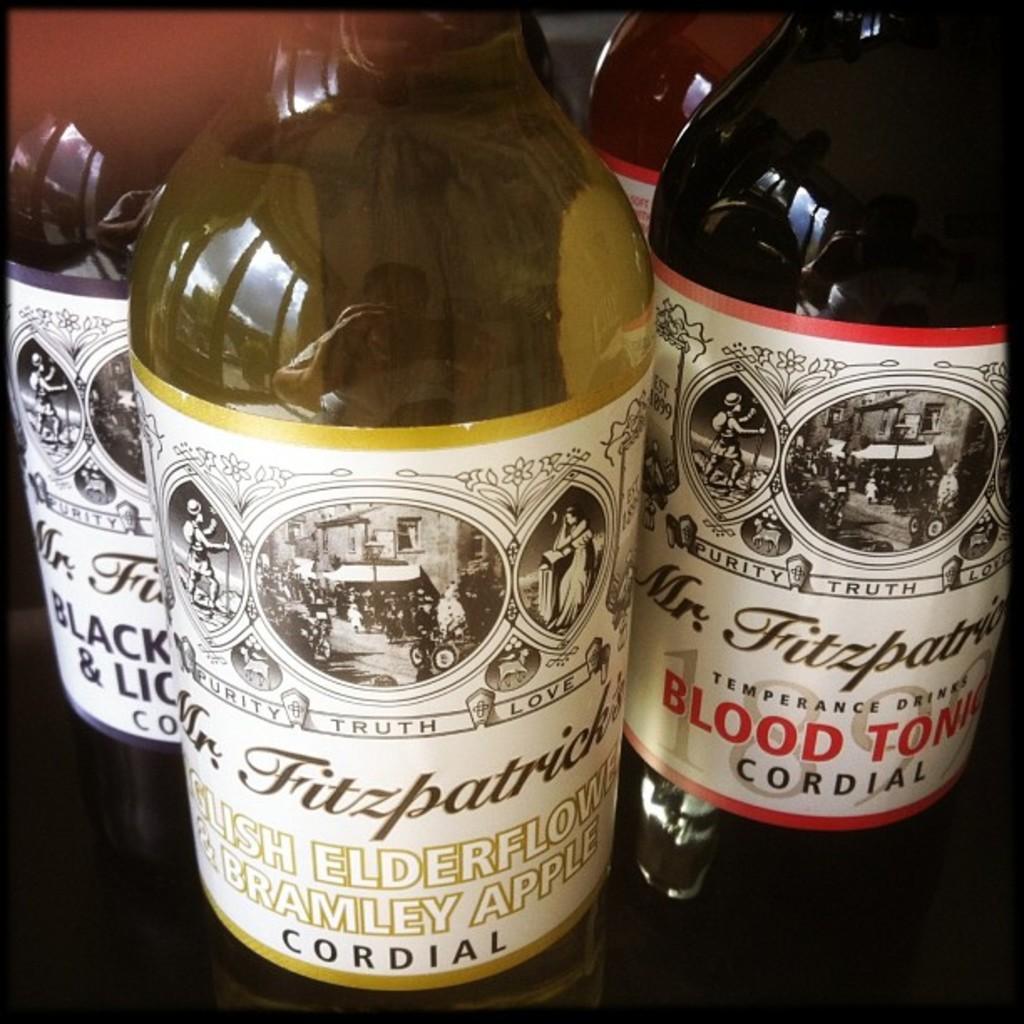What brand of cordial is this?
Ensure brevity in your answer.  Mr. fitzpatrick. What is one of the flavors of the cordial?
Offer a very short reply. Blood tonic. 